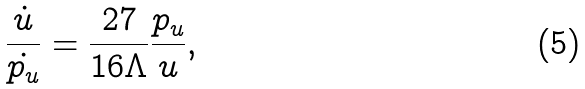<formula> <loc_0><loc_0><loc_500><loc_500>\frac { \dot { u } } { \dot { p _ { u } } } = \frac { 2 7 } { 1 6 \Lambda } \frac { p _ { u } } { u } ,</formula> 